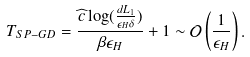<formula> <loc_0><loc_0><loc_500><loc_500>T _ { S P - G D } = \frac { \widehat { c } \log ( \frac { d L _ { 1 } } { \epsilon _ { H } \delta } ) } { \beta \epsilon _ { H } } + 1 \sim \mathcal { O } \left ( \frac { 1 } { \epsilon _ { H } } \right ) .</formula> 